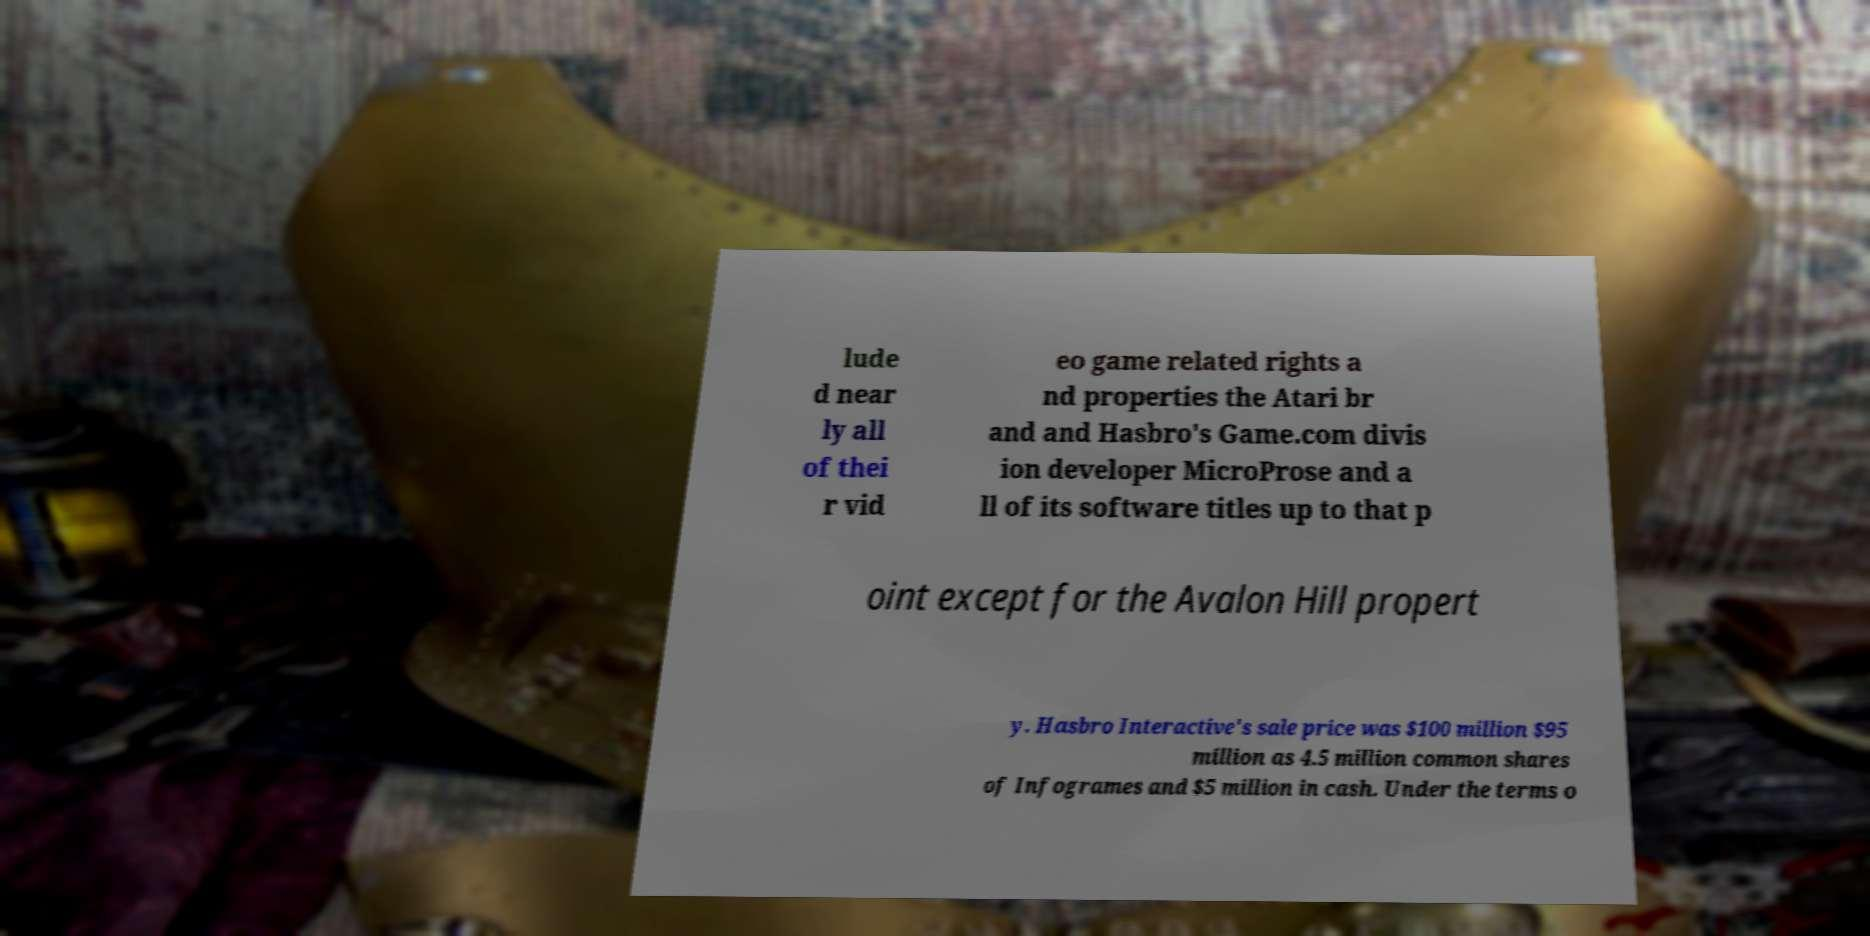For documentation purposes, I need the text within this image transcribed. Could you provide that? lude d near ly all of thei r vid eo game related rights a nd properties the Atari br and and Hasbro's Game.com divis ion developer MicroProse and a ll of its software titles up to that p oint except for the Avalon Hill propert y. Hasbro Interactive's sale price was $100 million $95 million as 4.5 million common shares of Infogrames and $5 million in cash. Under the terms o 